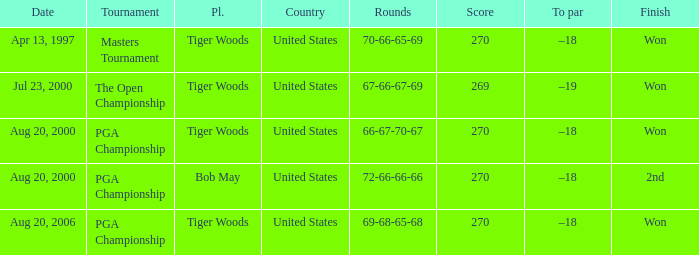What is the worst (highest) score? 270.0. 